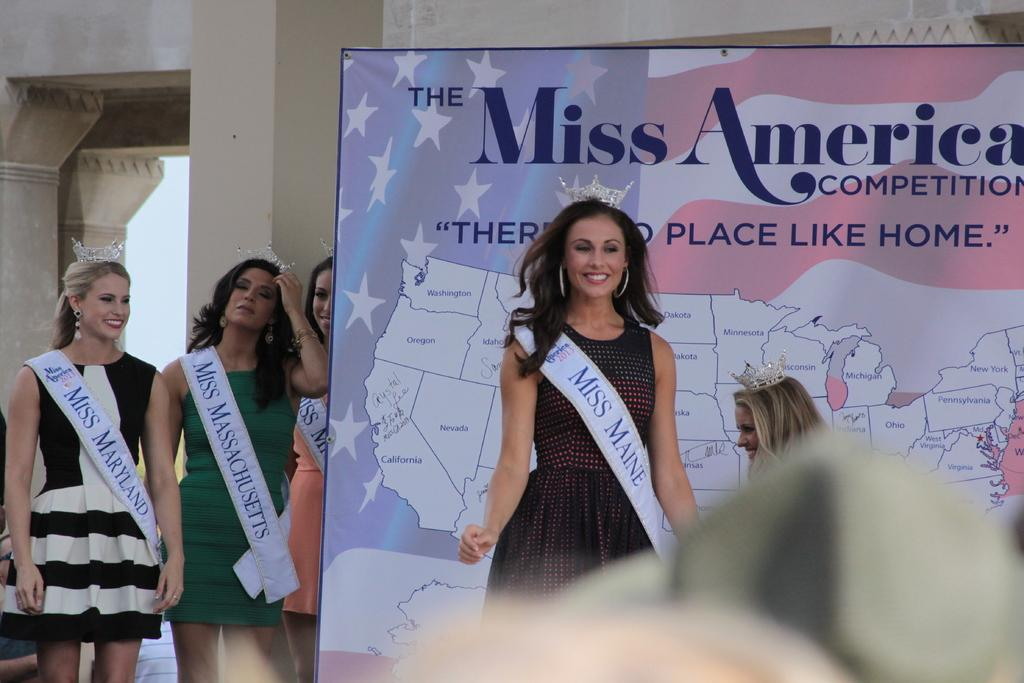<image>
Describe the image concisely. Miss Maine standing infront of a large map of the US 